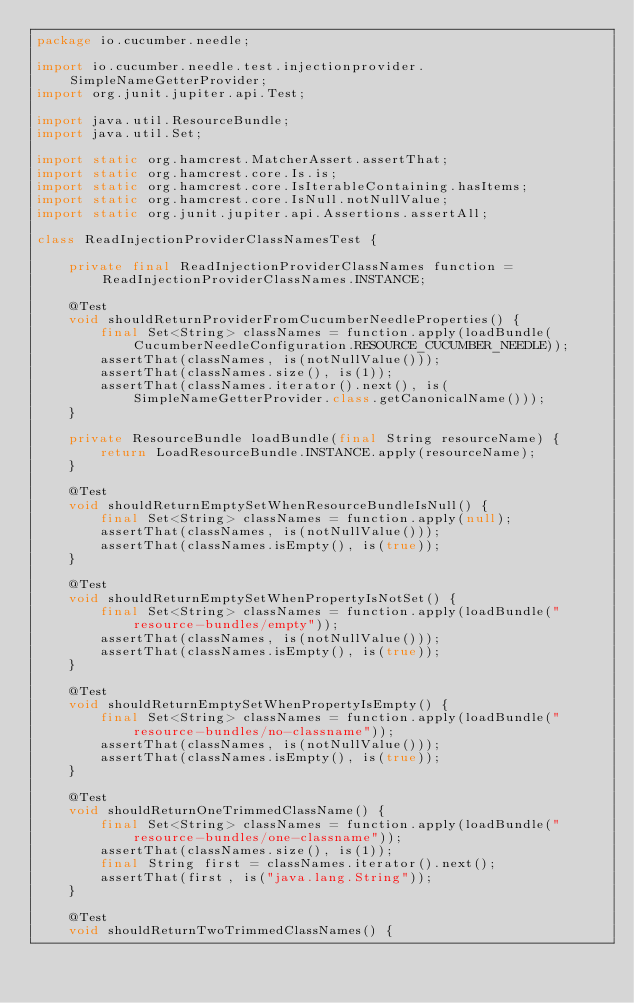Convert code to text. <code><loc_0><loc_0><loc_500><loc_500><_Java_>package io.cucumber.needle;

import io.cucumber.needle.test.injectionprovider.SimpleNameGetterProvider;
import org.junit.jupiter.api.Test;

import java.util.ResourceBundle;
import java.util.Set;

import static org.hamcrest.MatcherAssert.assertThat;
import static org.hamcrest.core.Is.is;
import static org.hamcrest.core.IsIterableContaining.hasItems;
import static org.hamcrest.core.IsNull.notNullValue;
import static org.junit.jupiter.api.Assertions.assertAll;

class ReadInjectionProviderClassNamesTest {

    private final ReadInjectionProviderClassNames function = ReadInjectionProviderClassNames.INSTANCE;

    @Test
    void shouldReturnProviderFromCucumberNeedleProperties() {
        final Set<String> classNames = function.apply(loadBundle(CucumberNeedleConfiguration.RESOURCE_CUCUMBER_NEEDLE));
        assertThat(classNames, is(notNullValue()));
        assertThat(classNames.size(), is(1));
        assertThat(classNames.iterator().next(), is(SimpleNameGetterProvider.class.getCanonicalName()));
    }

    private ResourceBundle loadBundle(final String resourceName) {
        return LoadResourceBundle.INSTANCE.apply(resourceName);
    }

    @Test
    void shouldReturnEmptySetWhenResourceBundleIsNull() {
        final Set<String> classNames = function.apply(null);
        assertThat(classNames, is(notNullValue()));
        assertThat(classNames.isEmpty(), is(true));
    }

    @Test
    void shouldReturnEmptySetWhenPropertyIsNotSet() {
        final Set<String> classNames = function.apply(loadBundle("resource-bundles/empty"));
        assertThat(classNames, is(notNullValue()));
        assertThat(classNames.isEmpty(), is(true));
    }

    @Test
    void shouldReturnEmptySetWhenPropertyIsEmpty() {
        final Set<String> classNames = function.apply(loadBundle("resource-bundles/no-classname"));
        assertThat(classNames, is(notNullValue()));
        assertThat(classNames.isEmpty(), is(true));
    }

    @Test
    void shouldReturnOneTrimmedClassName() {
        final Set<String> classNames = function.apply(loadBundle("resource-bundles/one-classname"));
        assertThat(classNames.size(), is(1));
        final String first = classNames.iterator().next();
        assertThat(first, is("java.lang.String"));
    }

    @Test
    void shouldReturnTwoTrimmedClassNames() {</code> 